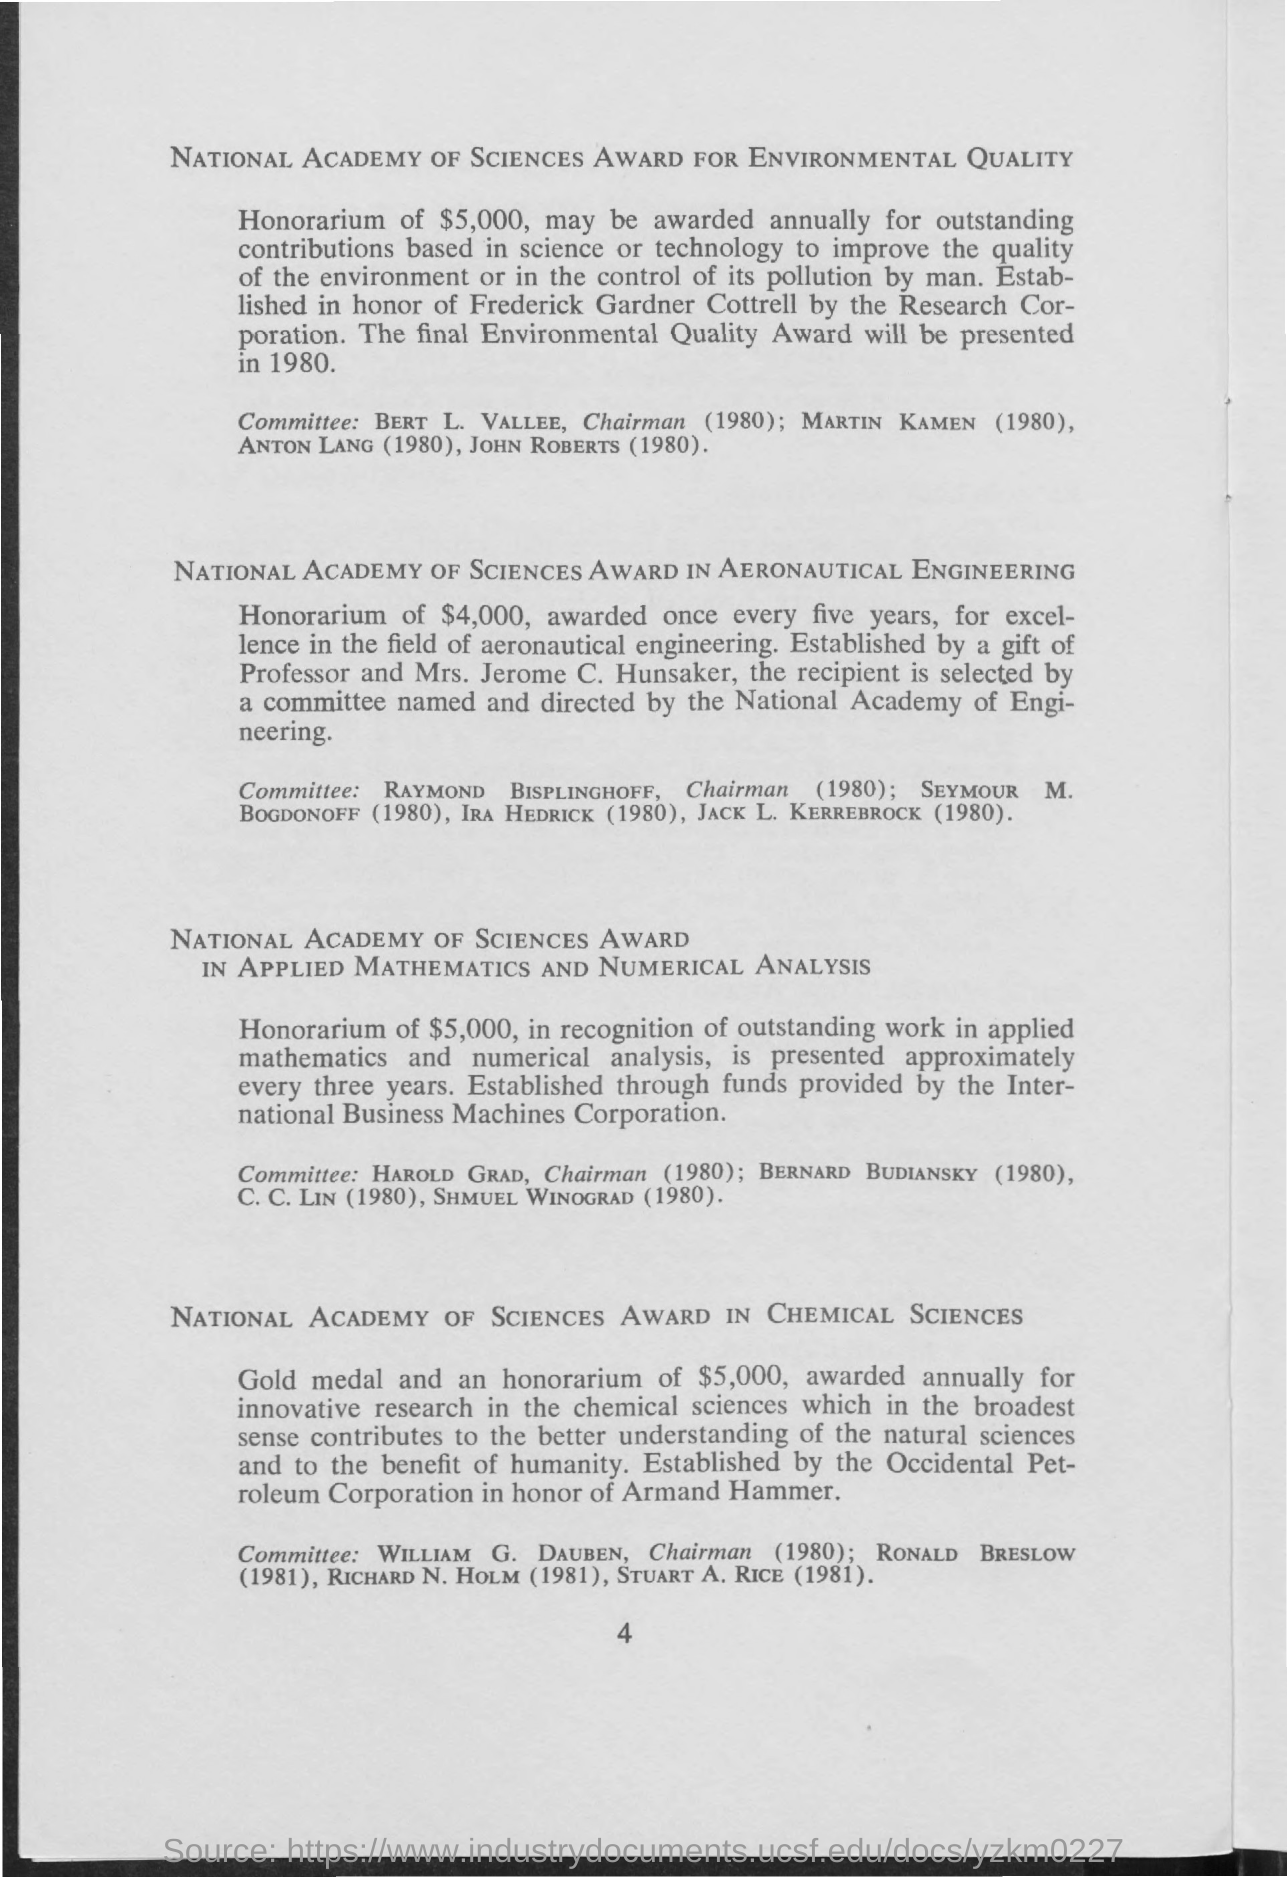What is the Honorarium for outstanding contributions based in science or technology?
Make the answer very short. $5,000. What is the Honorarium for excellence in the field of aeronautical engineering?
Make the answer very short. $4,000. 